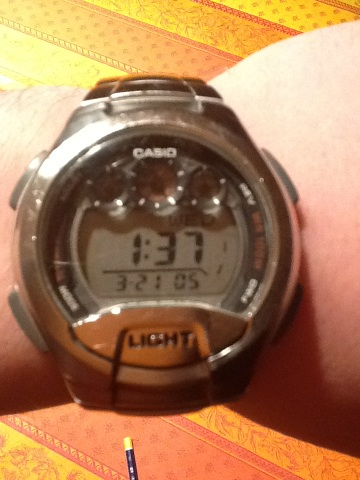What time is it? from Vizwiz 1:37 